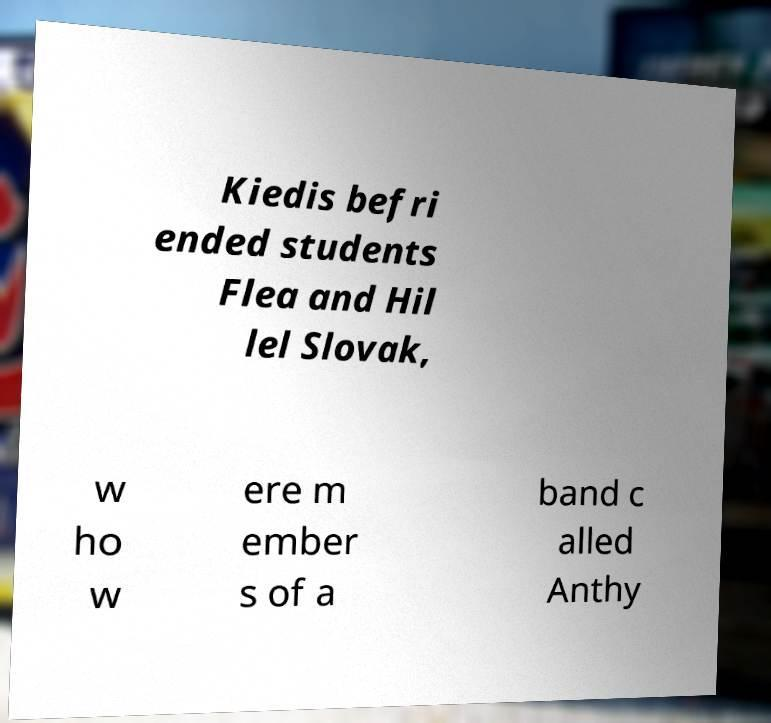What messages or text are displayed in this image? I need them in a readable, typed format. Kiedis befri ended students Flea and Hil lel Slovak, w ho w ere m ember s of a band c alled Anthy 